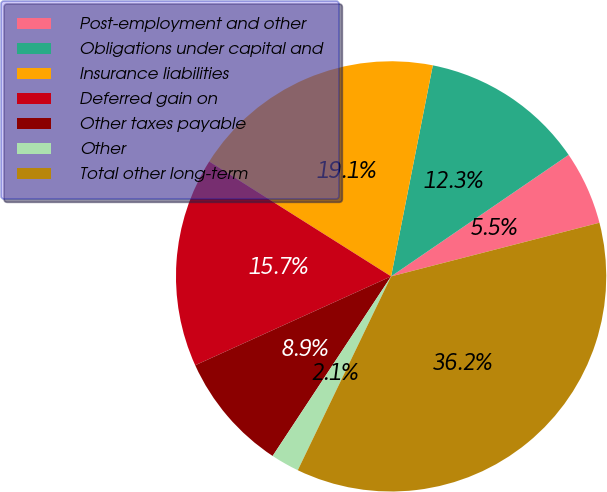<chart> <loc_0><loc_0><loc_500><loc_500><pie_chart><fcel>Post-employment and other<fcel>Obligations under capital and<fcel>Insurance liabilities<fcel>Deferred gain on<fcel>Other taxes payable<fcel>Other<fcel>Total other long-term<nl><fcel>5.54%<fcel>12.34%<fcel>19.14%<fcel>15.74%<fcel>8.94%<fcel>2.14%<fcel>36.15%<nl></chart> 